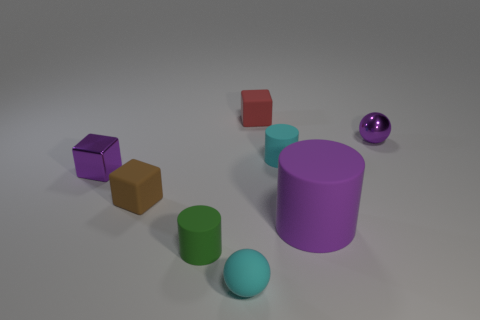Add 1 purple matte cylinders. How many objects exist? 9 Subtract all blocks. How many objects are left? 5 Subtract 1 purple cylinders. How many objects are left? 7 Subtract all big cylinders. Subtract all purple metal spheres. How many objects are left? 6 Add 4 purple shiny spheres. How many purple shiny spheres are left? 5 Add 4 large matte things. How many large matte things exist? 5 